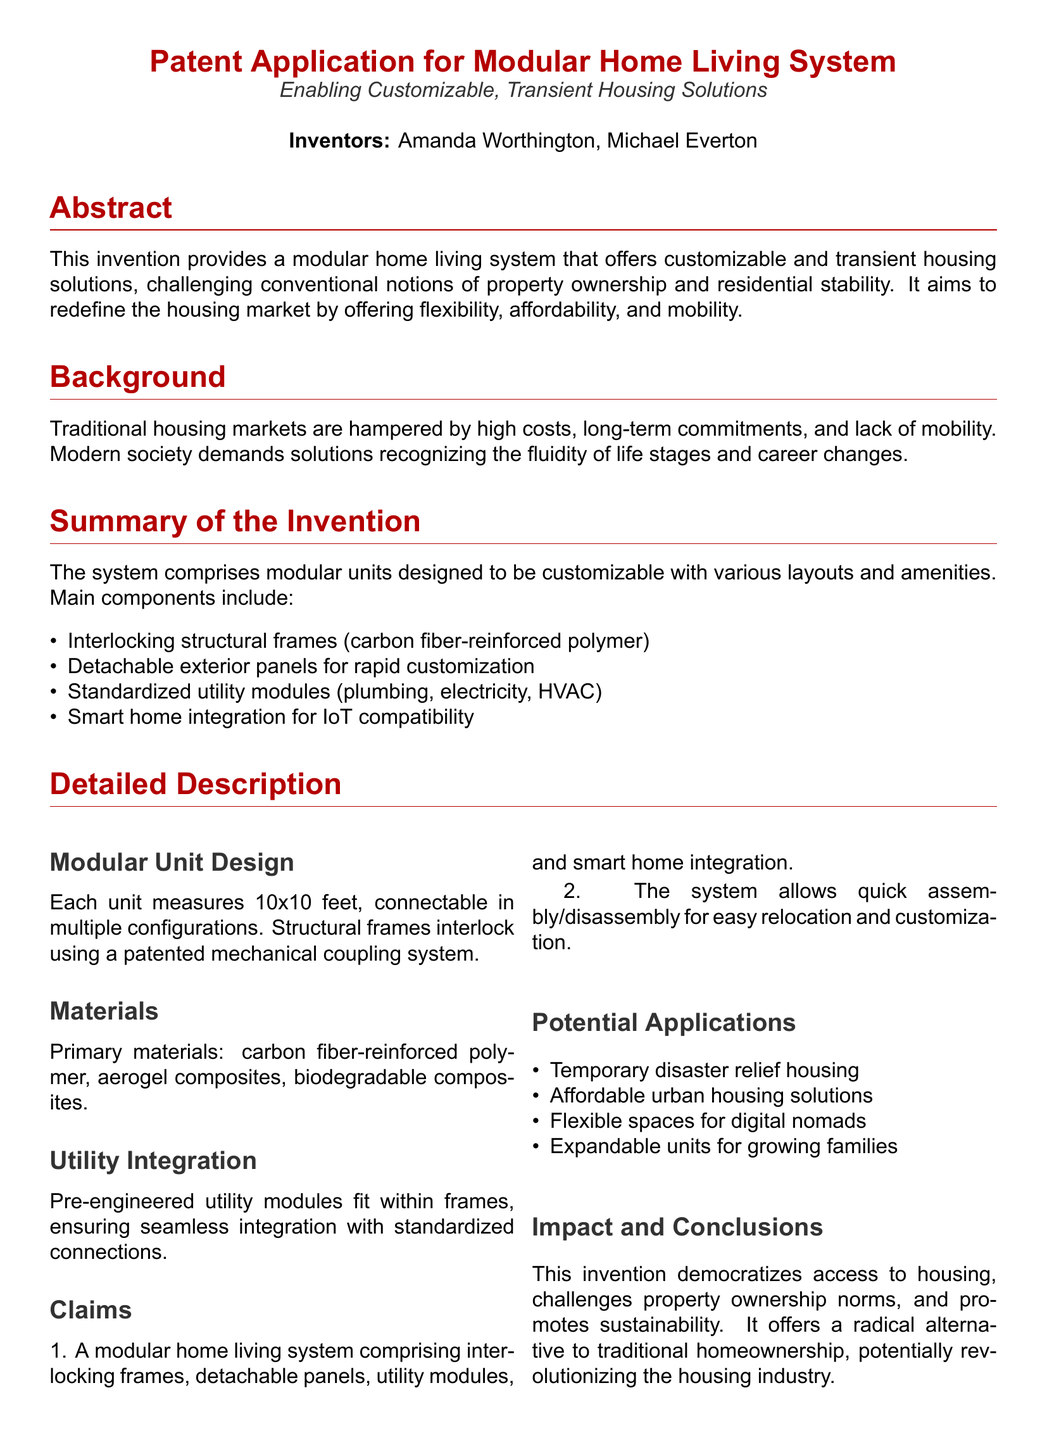What is the title of the patent application? The title of the patent application is provided in the header section of the document, articulating the focus of the invention.
Answer: Patent Application for Modular Home Living System Who are the inventors of the modular home living system? The names of the inventors are listed right under the title, emphasizing their contribution to the invention.
Answer: Amanda Worthington, Michael Everton What materials are primarily used in the modular units? The materials section lists the primary materials employed in the construction of the modular units in detail.
Answer: Carbon fiber-reinforced polymer, aerogel composites, biodegradable composites What is the purpose of the smart home integration mentioned in the document? The smart home integration signifies the ability of the system to connect with Internet of Things devices, enhancing user experience and functionality.
Answer: IoT compatibility What are potential applications of this modular home living system? The potential applications are outlined in a bullet-point format, illustrating the diverse contexts in which the invention could be utilized.
Answer: Temporary disaster relief housing, affordable urban housing solutions, flexible spaces for digital nomads, expandable units for growing families How does this invention challenge conventional ideas? The document states that the invention aims to redefine the housing market by promoting flexibility, affordability, and mobility, countering the norm of property ownership.
Answer: Challenges property ownership norms What is the size of each modular unit? The document specifies the dimensions of the modular units, which are fundamental for understanding their design and application.
Answer: 10x10 feet What is a key feature of the modular home living system? The claims section highlights a crucial element of the system, indicating its unique selling point.
Answer: Interlocking frames 